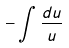Convert formula to latex. <formula><loc_0><loc_0><loc_500><loc_500>- \int \frac { d u } { u }</formula> 